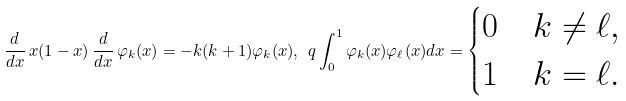<formula> <loc_0><loc_0><loc_500><loc_500>\frac { d } { d x } \, x ( 1 - x ) \, \frac { d } { d x } \, \varphi _ { k } ( x ) = - k ( k + 1 ) \varphi _ { k } ( x ) , \ q \int ^ { 1 } _ { 0 } \varphi _ { k } ( x ) \varphi _ { \ell } ( x ) d x = \begin{cases} 0 & k \ne \ell , \\ 1 & k = \ell . \end{cases}</formula> 